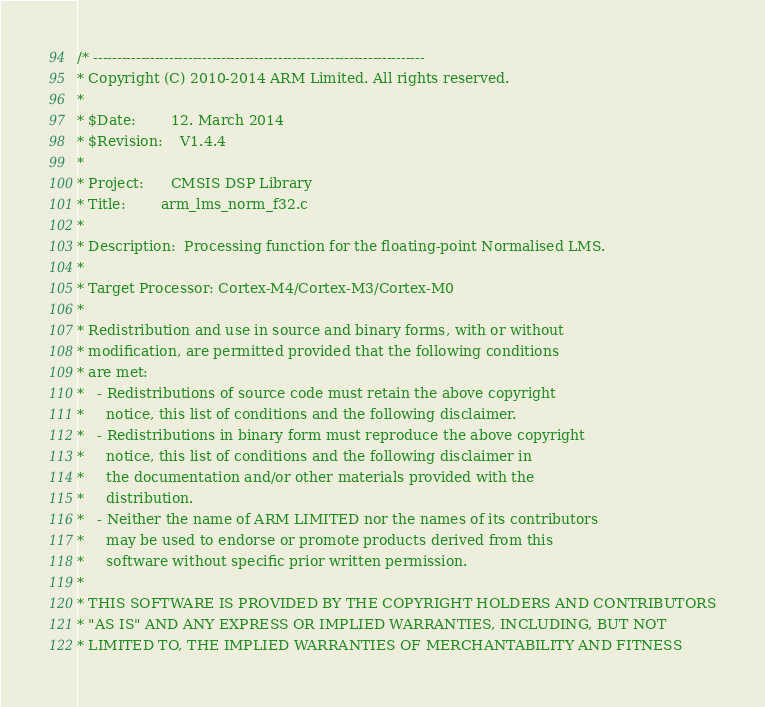<code> <loc_0><loc_0><loc_500><loc_500><_C_>/* ----------------------------------------------------------------------    
* Copyright (C) 2010-2014 ARM Limited. All rights reserved.    
*    
* $Date:        12. March 2014
* $Revision: 	V1.4.4
*    
* Project: 	    CMSIS DSP Library    
* Title:	    arm_lms_norm_f32.c    
*    
* Description:	Processing function for the floating-point Normalised LMS.    
*    
* Target Processor: Cortex-M4/Cortex-M3/Cortex-M0
*  
* Redistribution and use in source and binary forms, with or without 
* modification, are permitted provided that the following conditions
* are met:
*   - Redistributions of source code must retain the above copyright
*     notice, this list of conditions and the following disclaimer.
*   - Redistributions in binary form must reproduce the above copyright
*     notice, this list of conditions and the following disclaimer in
*     the documentation and/or other materials provided with the 
*     distribution.
*   - Neither the name of ARM LIMITED nor the names of its contributors
*     may be used to endorse or promote products derived from this
*     software without specific prior written permission.
*
* THIS SOFTWARE IS PROVIDED BY THE COPYRIGHT HOLDERS AND CONTRIBUTORS
* "AS IS" AND ANY EXPRESS OR IMPLIED WARRANTIES, INCLUDING, BUT NOT
* LIMITED TO, THE IMPLIED WARRANTIES OF MERCHANTABILITY AND FITNESS</code> 